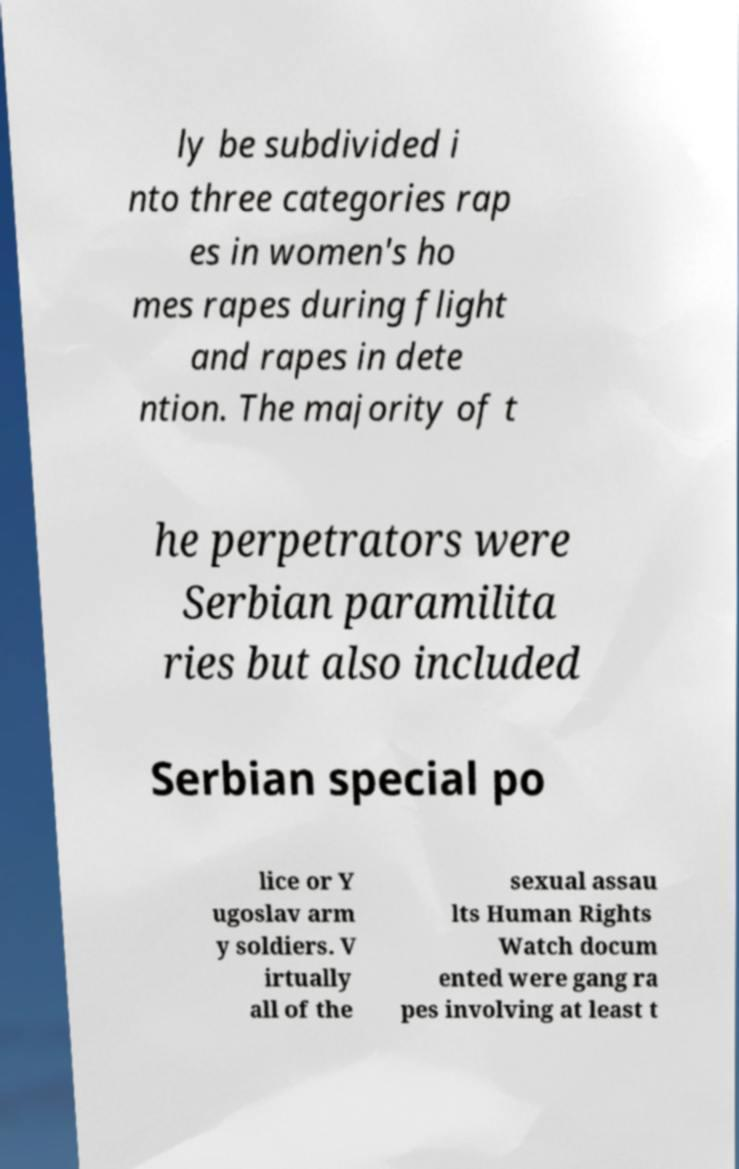What messages or text are displayed in this image? I need them in a readable, typed format. ly be subdivided i nto three categories rap es in women's ho mes rapes during flight and rapes in dete ntion. The majority of t he perpetrators were Serbian paramilita ries but also included Serbian special po lice or Y ugoslav arm y soldiers. V irtually all of the sexual assau lts Human Rights Watch docum ented were gang ra pes involving at least t 